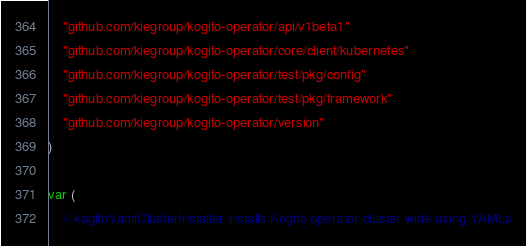Convert code to text. <code><loc_0><loc_0><loc_500><loc_500><_Go_>	"github.com/kiegroup/kogito-operator/api/v1beta1"
	"github.com/kiegroup/kogito-operator/core/client/kubernetes"
	"github.com/kiegroup/kogito-operator/test/pkg/config"
	"github.com/kiegroup/kogito-operator/test/pkg/framework"
	"github.com/kiegroup/kogito-operator/version"
)

var (
	// kogitoYamlClusterInstaller installs Kogito operator cluster wide using YAMLs</code> 